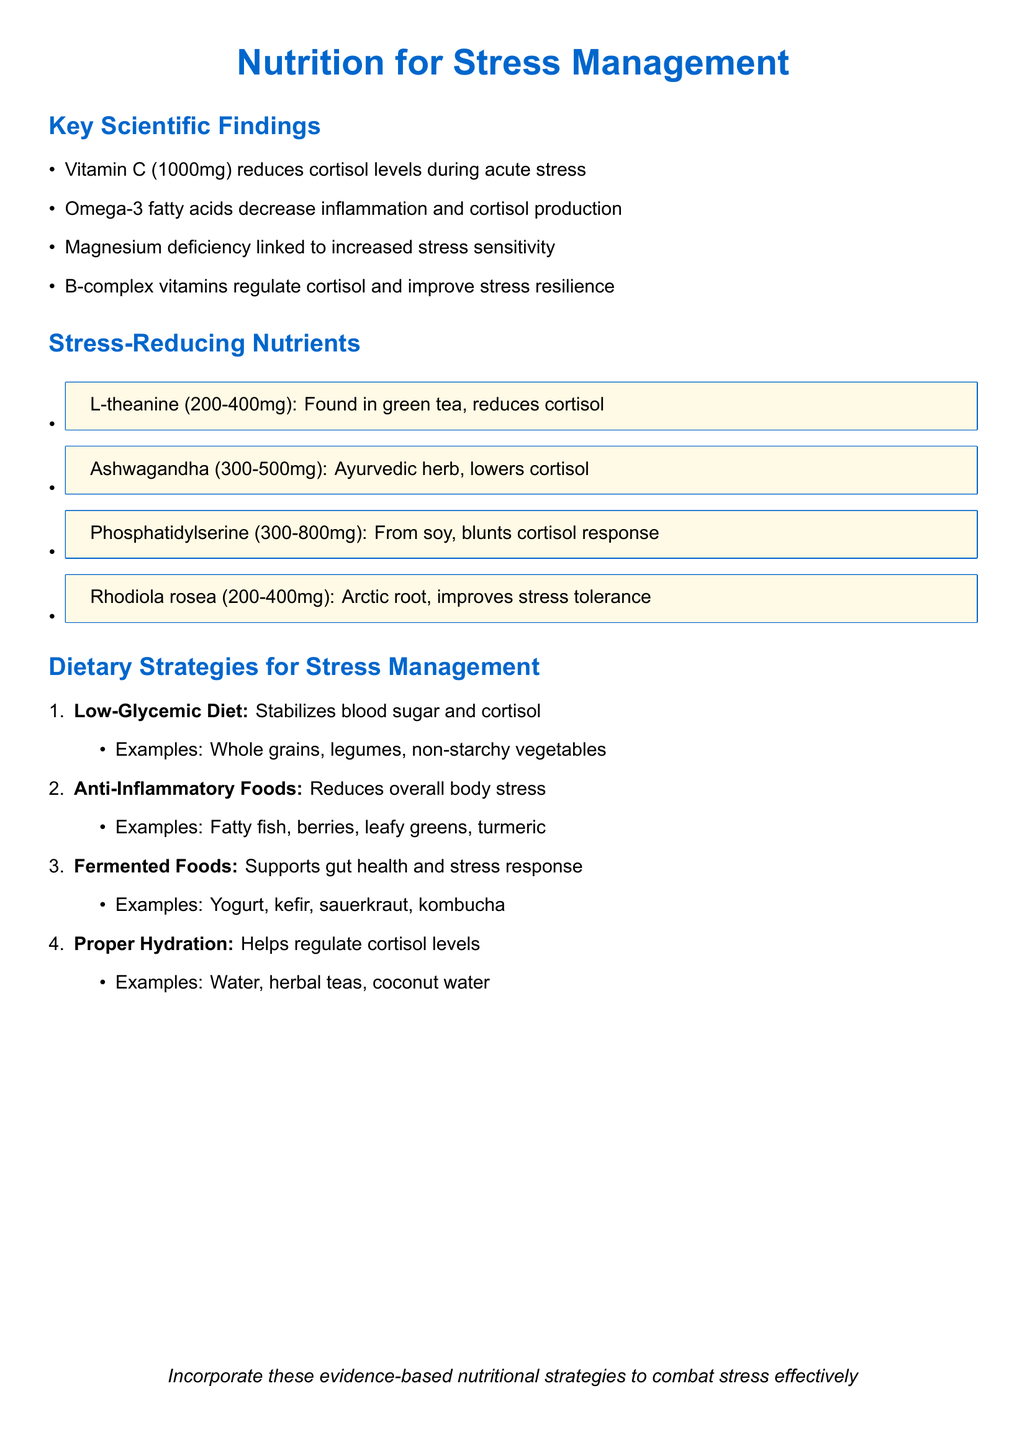What year was the study on Vitamin C published? The document states that Vitamin C Supplementation and Cortisol Response to Acute Psychological Stress was published in 2022.
Answer: 2022 Who are the authors of the study on Omega-3 Fatty Acids? The authors of the study are Kiecolt-Glaser, Belury, Andridge, Malarkey, and Glaser.
Answer: Kiecolt-Glaser JK, Belury MA, Andridge R, Malarkey WB, Glaser R What dosage of Ashwagandha is recommended? The document specifies that the recommended dosage of Ashwagandha extract is 300-500mg daily.
Answer: 300-500mg Which dietary strategy is mentioned for stabilizing blood sugar? The dietary strategy that stabilizes blood sugar levels is the Low-Glycemic Diet.
Answer: Low-Glycemic Diet What nutrient is associated with cortisol reduction from green tea? L-theanine is the nutrient derived from green tea that reduces cortisol levels.
Answer: L-theanine How do B-complex vitamins affect stress management? The document states that B-complex vitamins help regulate cortisol production and improve stress resilience.
Answer: Regulate cortisol production and improve stress resilience What is a common effect of Omega-3 supplementation? Omega-3 supplementation is noted for reducing inflammation and cortisol production during stressful events.
Answer: Reduces inflammation and cortisol production Which food examples are listed under Anti-Inflammatory Foods? The examples of Anti-Inflammatory Foods include fatty fish, berries, leafy greens, and turmeric.
Answer: Fatty fish, berries, leafy greens, turmeric 